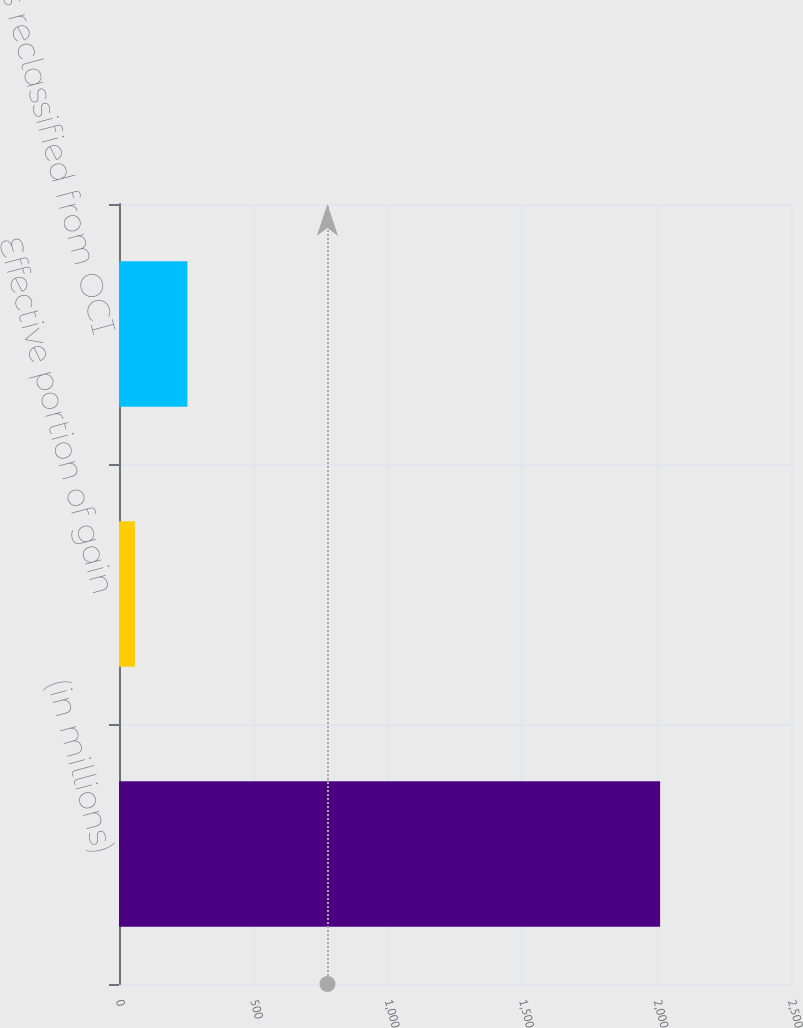Convert chart to OTSL. <chart><loc_0><loc_0><loc_500><loc_500><bar_chart><fcel>(in millions)<fcel>Effective portion of gain<fcel>Amounts reclassified from OCI<nl><fcel>2013<fcel>59<fcel>254.4<nl></chart> 